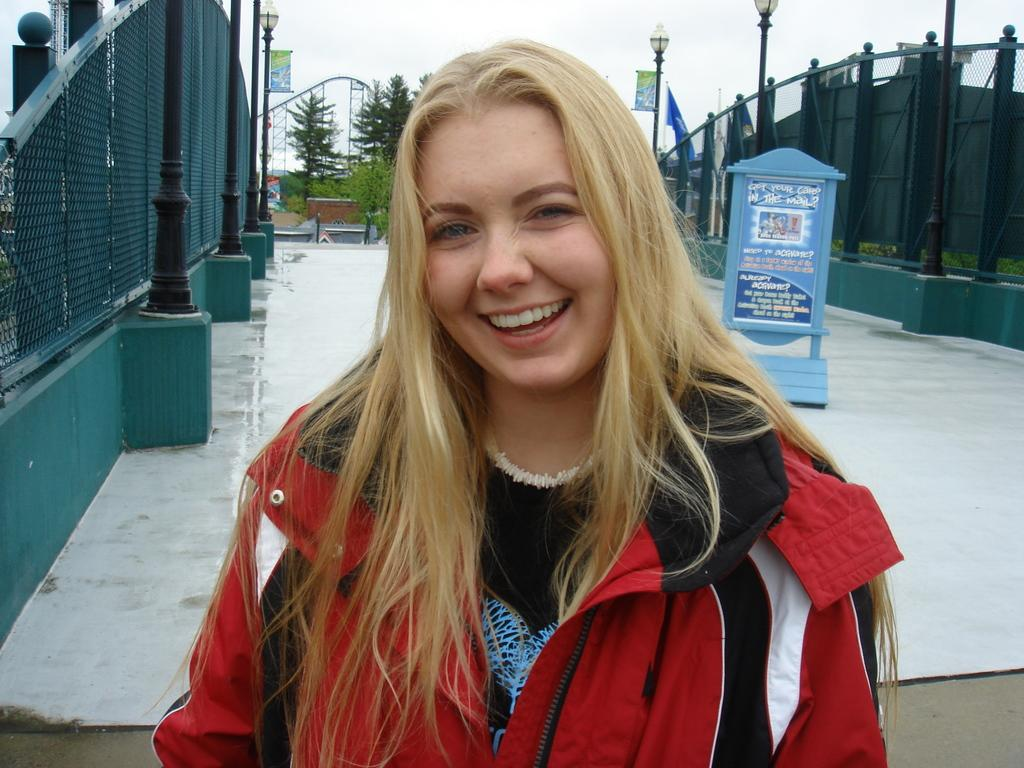Who is present in the image? There is a lady in the image. What can be seen on the sides of the image? There is fencing on the sides of the image. What structures are visible in the image? There are light poles in the image. What object is present in the image that might be used for displaying information? There is a board in the image. What type of natural scenery is visible in the background of the image? There are trees in the background of the image. What part of the natural environment is visible in the background of the image? The sky is visible in the background of the image. What type of legal advice is the lady providing in the image? There is no indication in the image that the lady is providing legal advice or acting as a lawyer. 